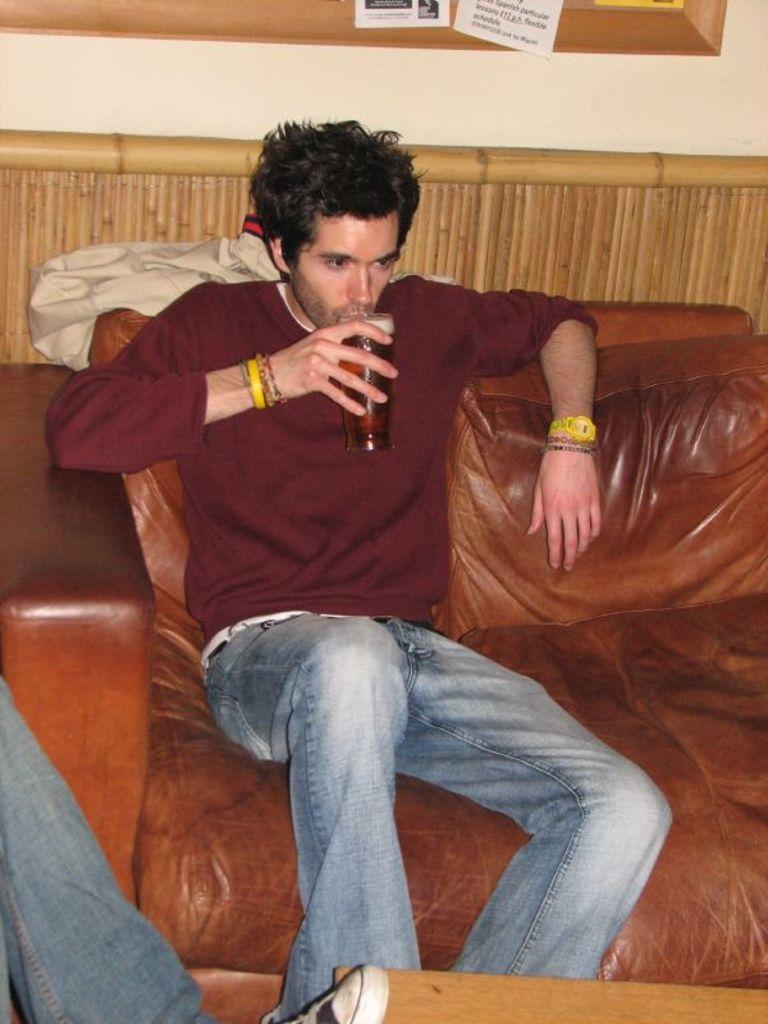How many people are in the image? There are two people in the image. Can you describe one of the people in the image? One person is a man. What is the man doing in the image? The man is sitting on a sofa and drinking from a glass. What is on the table in the image? The information provided does not specify what is on the table. What can be seen on the wall in the image? There is a frame on the wall in the image. Is the steam coming out of the man's glass in the image? There is no steam coming out of the man's glass in the image. What type of manager is present in the image? There is no manager present in the image. 